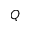<formula> <loc_0><loc_0><loc_500><loc_500>Q</formula> 